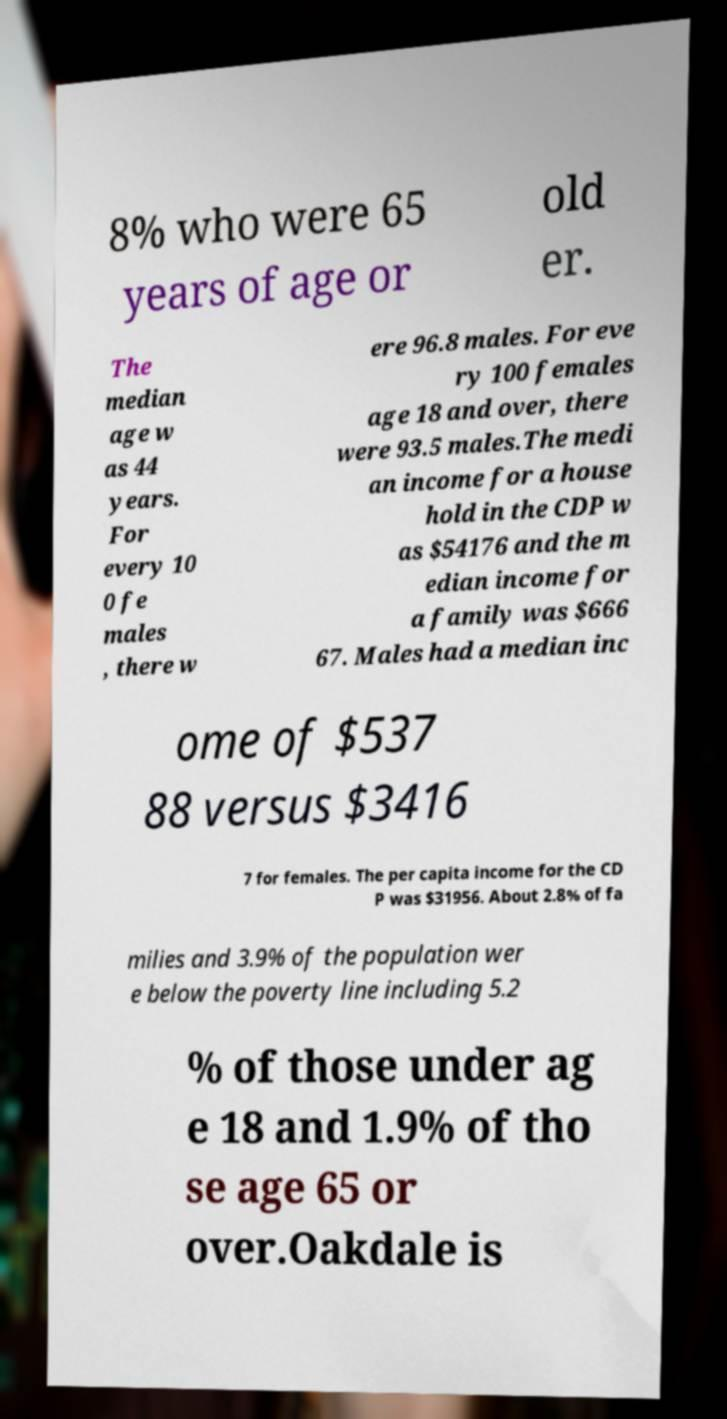Please read and relay the text visible in this image. What does it say? 8% who were 65 years of age or old er. The median age w as 44 years. For every 10 0 fe males , there w ere 96.8 males. For eve ry 100 females age 18 and over, there were 93.5 males.The medi an income for a house hold in the CDP w as $54176 and the m edian income for a family was $666 67. Males had a median inc ome of $537 88 versus $3416 7 for females. The per capita income for the CD P was $31956. About 2.8% of fa milies and 3.9% of the population wer e below the poverty line including 5.2 % of those under ag e 18 and 1.9% of tho se age 65 or over.Oakdale is 